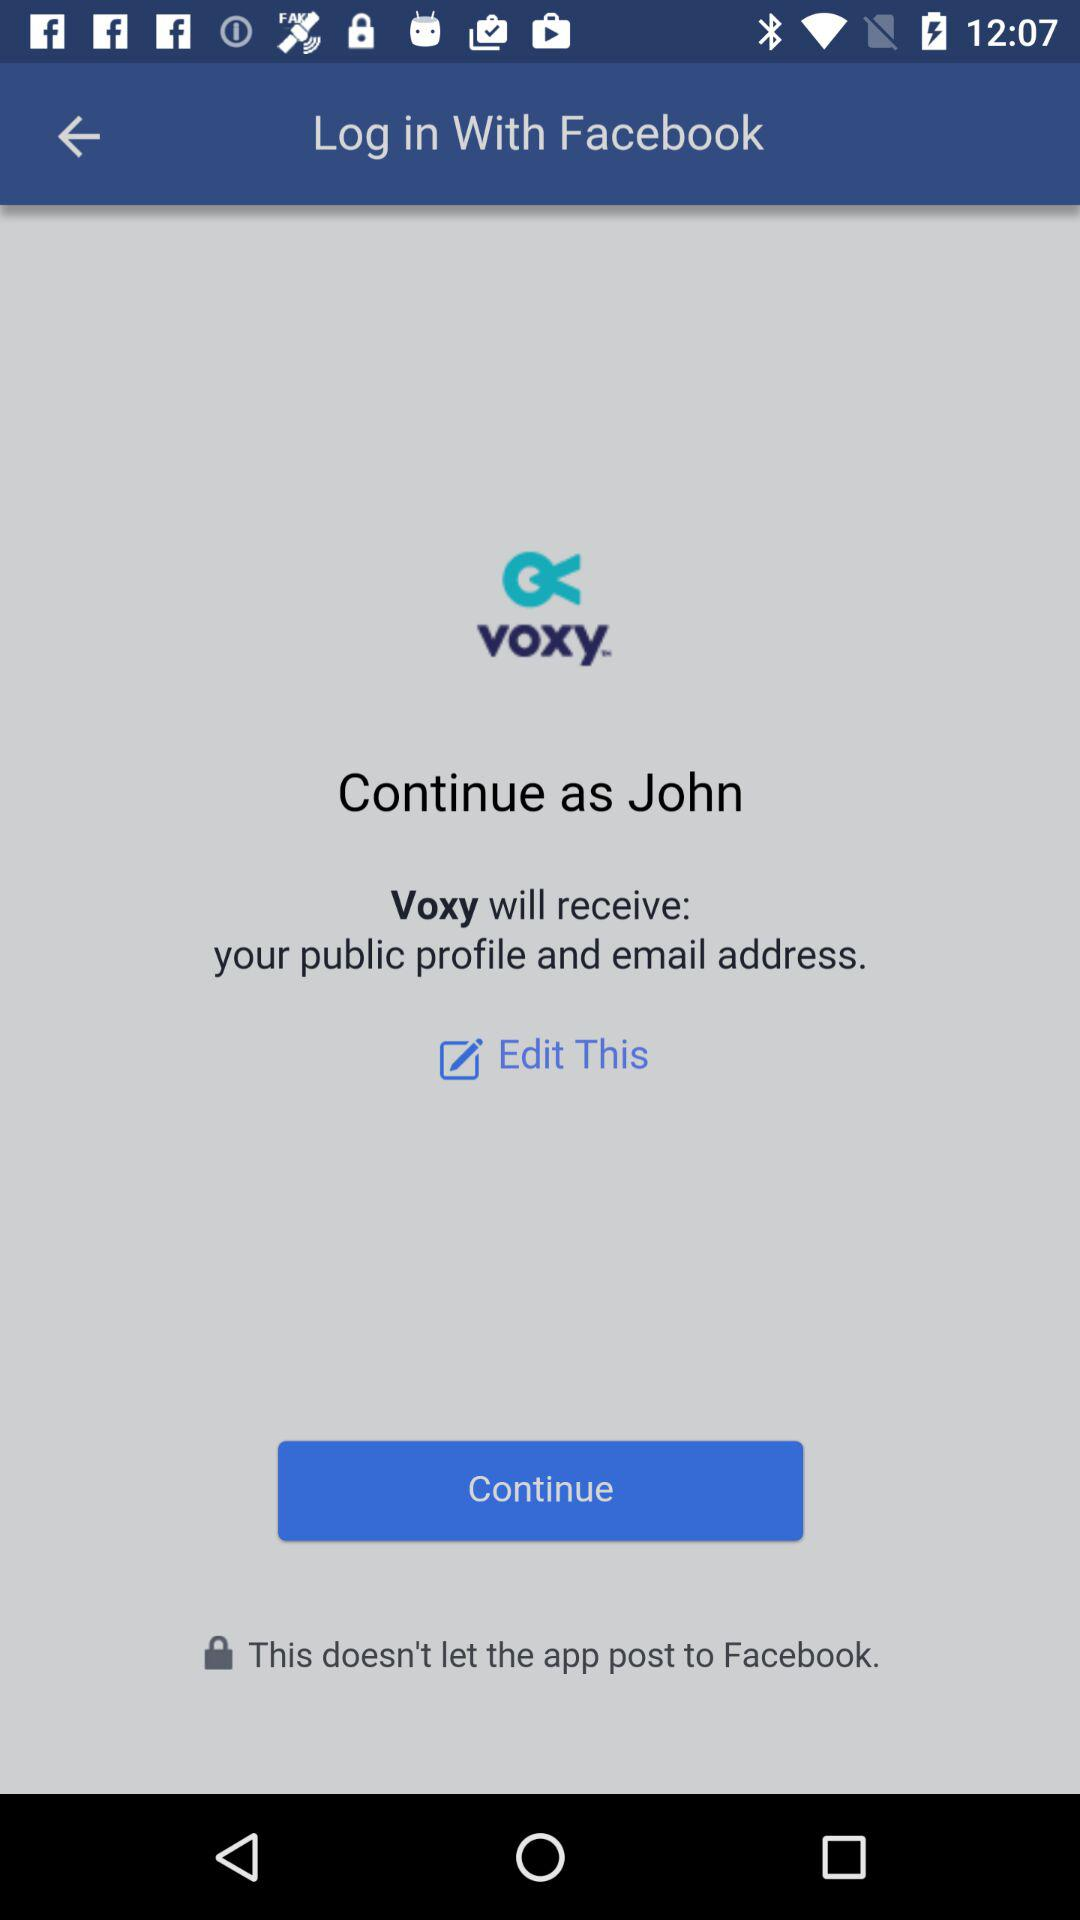What is the name of the user? The name of the user is John. 